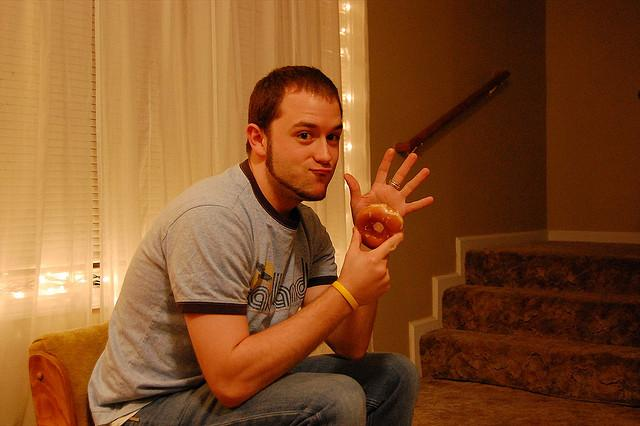What flavor is the donut?

Choices:
A) chocolate
B) carrot
C) caramel
D) lemon caramel 